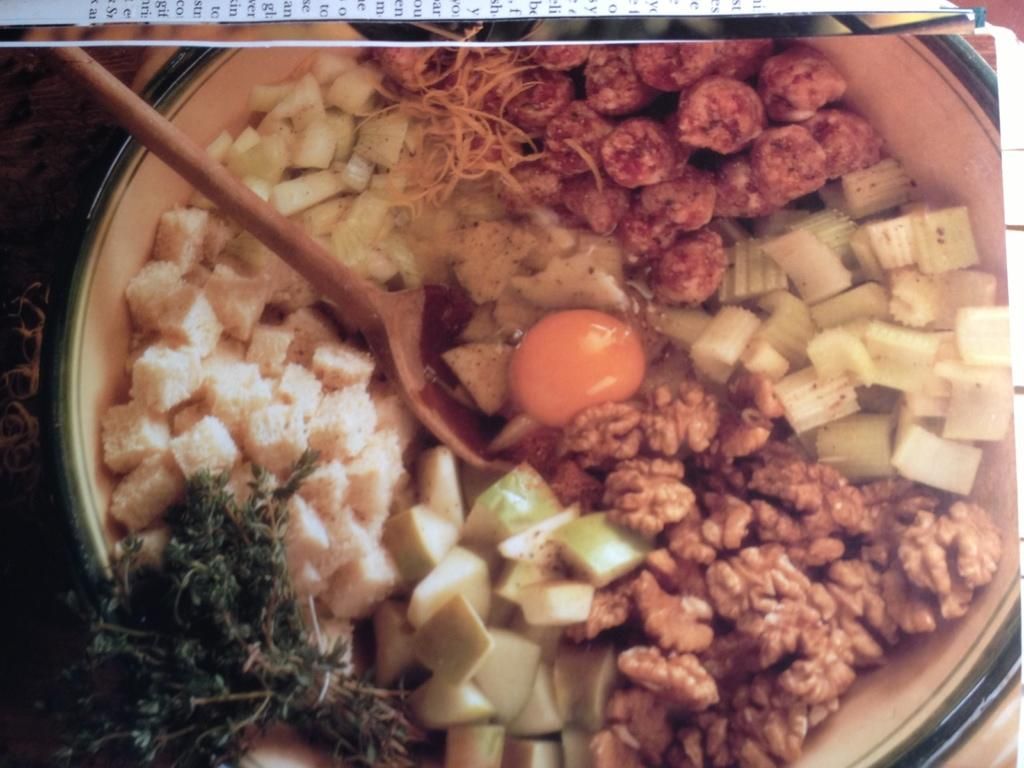What is present in the image that can hold food? There is a bowl in the image that can hold food. What type of food can be seen in the bowl? There are food items in the bowl. What utensil is used to eat the food in the bowl? There is a brown-colored spoon in the bowl. What type of string is attached to the food in the bowl? There is no string attached to the food in the bowl; it is simply placed in the bowl. 